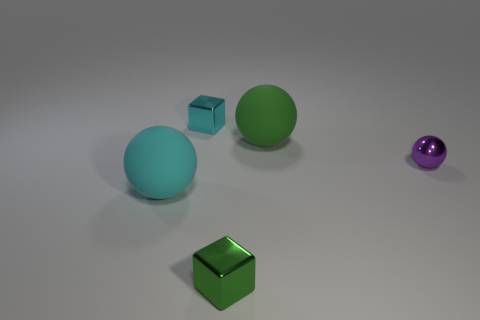How many objects are there in the image, and can you describe them? There are five objects in the image. Starting from the left, there is a light blue translucent sphere, followed by a green rubber cube. Next to it sits a slightly larger green rubber sphere, and to the right, we have another, smaller cube with a cyan metallic appearance. Finally, on the far right, there is the small purple sphere I described previously. 